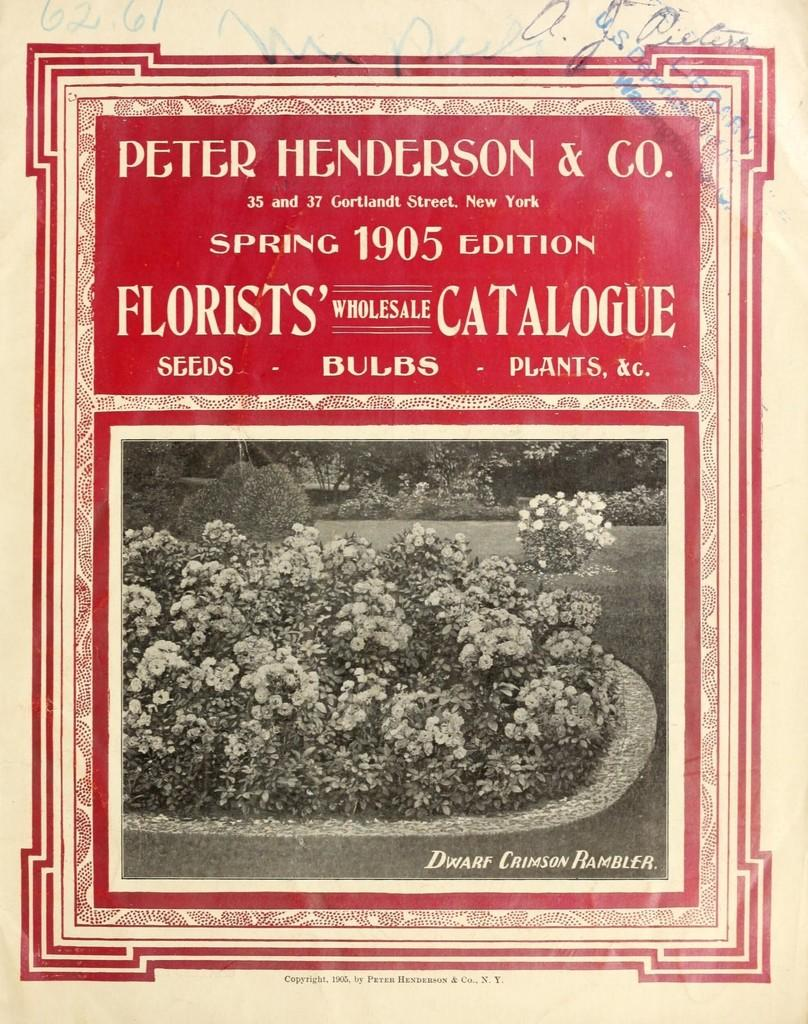What type of living organisms can be seen in the image? Plants can be seen in the image. Do the plants have any specific features? Yes, the plants have flowers. What is written above the plants in the image? There is text written above the plants. Can you tell me how many donkeys are visible in the image? There are no donkeys present in the image; it features plants with flowers and text written above them. What type of powder is being used to water the plants in the image? There is no powder visible in the image, and the plants do not appear to be receiving any water. 